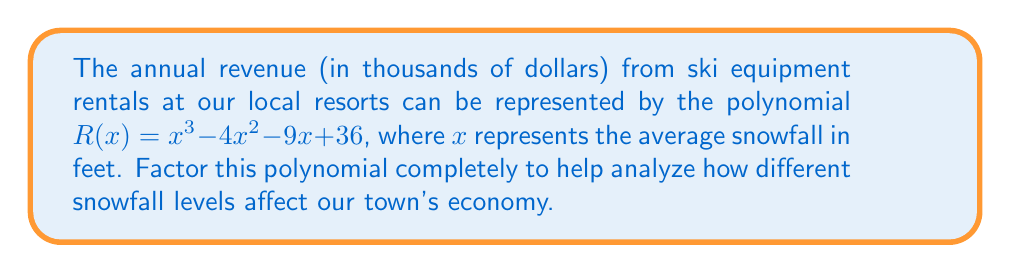Show me your answer to this math problem. Let's factor this polynomial step by step:

1) First, let's check if there are any common factors. There are none, so we proceed.

2) This is a cubic polynomial. Let's try to find a factor by guessing roots. The possible rational roots are the factors of the constant term: ±1, ±2, ±3, ±4, ±6, ±9, ±12, ±18, ±36.

3) Testing these values, we find that $R(3) = 0$. So $(x - 3)$ is a factor.

4) We can divide $R(x)$ by $(x - 3)$ using polynomial long division:

   $x^3 - 4x^2 - 9x + 36 = (x - 3)(x^2 - x - 12)$

5) Now we need to factor the quadratic $x^2 - x - 12$. We can do this by finding two numbers that multiply to give -12 and add to give -1.

6) These numbers are -4 and 3. So we can factor $x^2 - x - 12$ as $(x - 4)(x + 3)$.

7) Putting it all together, we have:

   $R(x) = (x - 3)(x - 4)(x + 3)$

This factorization shows that the revenue will be zero when the snowfall is 3 feet or 4 feet, and will be negative when snowfall is between 3 and 4 feet.
Answer: $R(x) = (x - 3)(x - 4)(x + 3)$ 